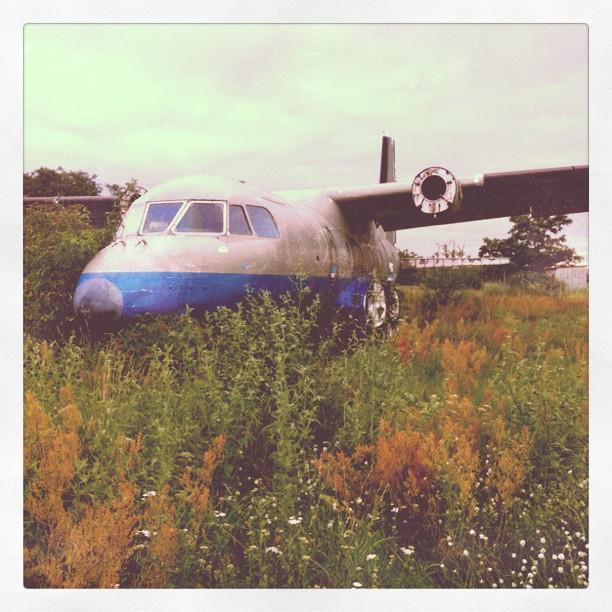Is the plane not working?
Answer briefly. Yes. Is this plane ready to take off?
Give a very brief answer. No. Is the plane at the airport?
Quick response, please. No. 